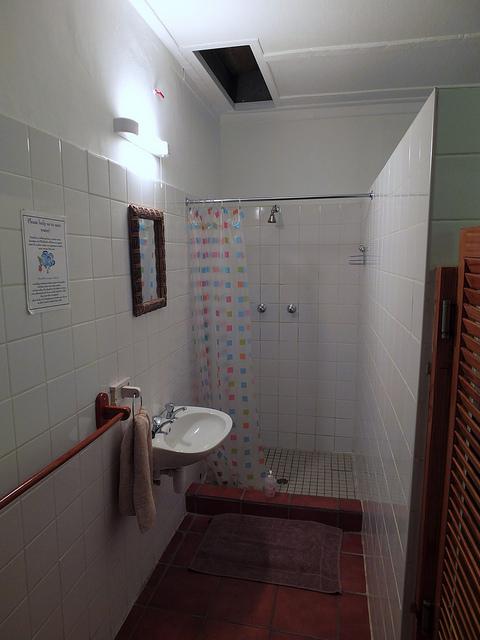What color is the mirror's frame?
Write a very short answer. Brown. What kind of notice is taped to the wall?
Write a very short answer. Wash hands. What room are they in?
Write a very short answer. Bathroom. What material are the doors to the shower made out of?
Be succinct. Plastic. 